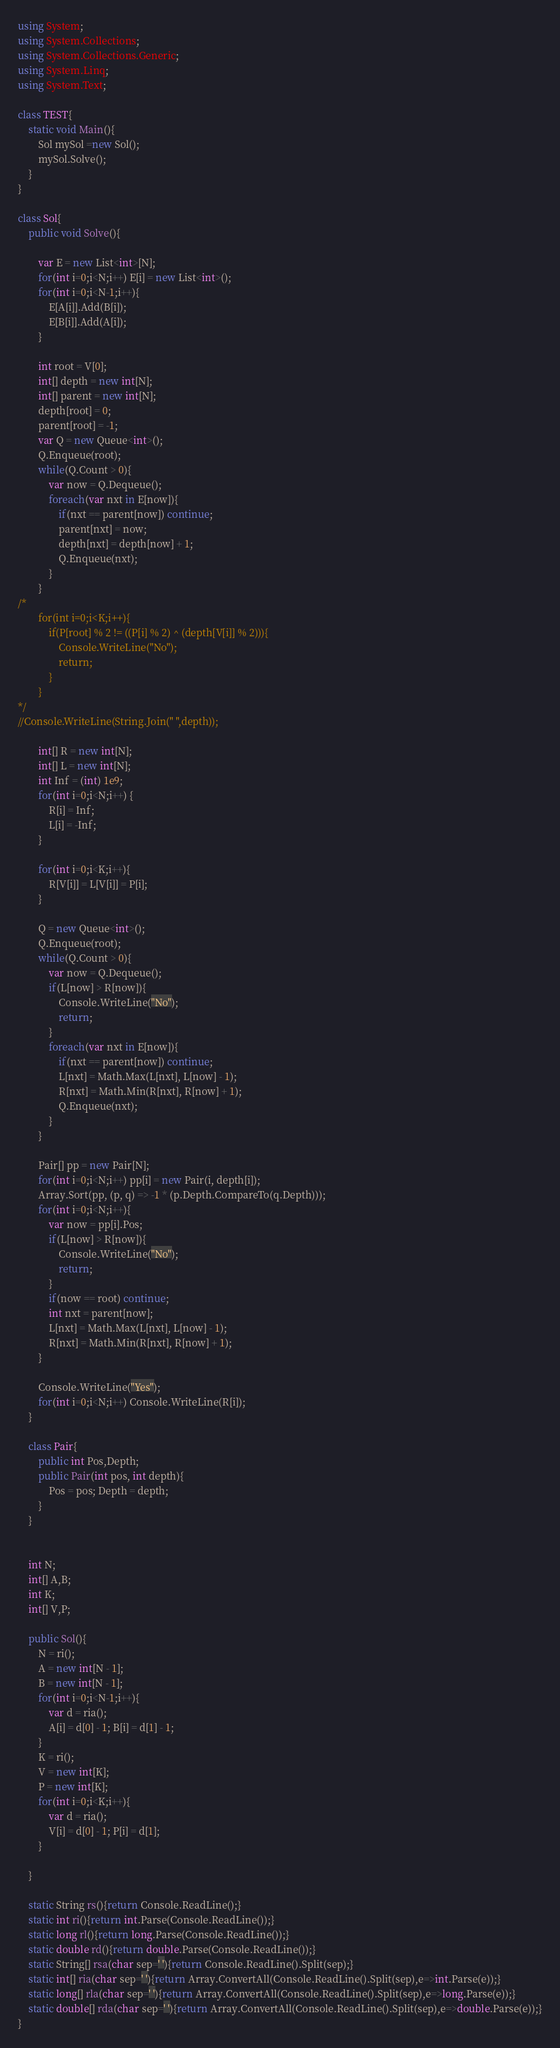Convert code to text. <code><loc_0><loc_0><loc_500><loc_500><_C#_>using System;
using System.Collections;
using System.Collections.Generic;
using System.Linq;
using System.Text;

class TEST{
	static void Main(){
		Sol mySol =new Sol();
		mySol.Solve();
	}
}

class Sol{
	public void Solve(){
		
		var E = new List<int>[N];
		for(int i=0;i<N;i++) E[i] = new List<int>();
		for(int i=0;i<N-1;i++){
			E[A[i]].Add(B[i]);
			E[B[i]].Add(A[i]);
		}
		
		int root = V[0];
		int[] depth = new int[N];
		int[] parent = new int[N];
		depth[root] = 0;
		parent[root] = -1;
		var Q = new Queue<int>();
		Q.Enqueue(root);
		while(Q.Count > 0){
			var now = Q.Dequeue();
			foreach(var nxt in E[now]){
				if(nxt == parent[now]) continue;
				parent[nxt] = now;
				depth[nxt] = depth[now] + 1;
				Q.Enqueue(nxt);
			}
		}
/*
		for(int i=0;i<K;i++){
			if(P[root] % 2 != ((P[i] % 2) ^ (depth[V[i]] % 2))){
				Console.WriteLine("No");
				return;
			}
		}
*/
//Console.WriteLine(String.Join(" ",depth));		
		
		int[] R = new int[N];
		int[] L = new int[N];
		int Inf = (int) 1e9;
		for(int i=0;i<N;i++) {
			R[i] = Inf;
			L[i] = -Inf;
		}
		
		for(int i=0;i<K;i++){
			R[V[i]] = L[V[i]] = P[i];
		}
		
		Q = new Queue<int>();
		Q.Enqueue(root);
		while(Q.Count > 0){
			var now = Q.Dequeue();
			if(L[now] > R[now]){
				Console.WriteLine("No");
				return;
			}
			foreach(var nxt in E[now]){
				if(nxt == parent[now]) continue;
				L[nxt] = Math.Max(L[nxt], L[now] - 1);
				R[nxt] = Math.Min(R[nxt], R[now] + 1);
				Q.Enqueue(nxt);
			}
		}
		
		Pair[] pp = new Pair[N];
		for(int i=0;i<N;i++) pp[i] = new Pair(i, depth[i]);
		Array.Sort(pp, (p, q) => -1 * (p.Depth.CompareTo(q.Depth)));
		for(int i=0;i<N;i++){
			var now = pp[i].Pos;
			if(L[now] > R[now]){
				Console.WriteLine("No");
				return;
			}
			if(now == root) continue;
			int nxt = parent[now];
			L[nxt] = Math.Max(L[nxt], L[now] - 1);
			R[nxt] = Math.Min(R[nxt], R[now] + 1);
		}
		
		Console.WriteLine("Yes");
		for(int i=0;i<N;i++) Console.WriteLine(R[i]);
	}
	
	class Pair{
		public int Pos,Depth;
		public Pair(int pos, int depth){
			Pos = pos; Depth = depth;
		}
	}
	
	
	int N;
	int[] A,B;
	int K;
	int[] V,P;
	
	public Sol(){
		N = ri();
		A = new int[N - 1];
		B = new int[N - 1];
		for(int i=0;i<N-1;i++){
			var d = ria();
			A[i] = d[0] - 1; B[i] = d[1] - 1;
		}
		K = ri();
		V = new int[K];
		P = new int[K];
		for(int i=0;i<K;i++){
			var d = ria();
			V[i] = d[0] - 1; P[i] = d[1];
		}
		
	}

	static String rs(){return Console.ReadLine();}
	static int ri(){return int.Parse(Console.ReadLine());}
	static long rl(){return long.Parse(Console.ReadLine());}
	static double rd(){return double.Parse(Console.ReadLine());}
	static String[] rsa(char sep=' '){return Console.ReadLine().Split(sep);}
	static int[] ria(char sep=' '){return Array.ConvertAll(Console.ReadLine().Split(sep),e=>int.Parse(e));}
	static long[] rla(char sep=' '){return Array.ConvertAll(Console.ReadLine().Split(sep),e=>long.Parse(e));}
	static double[] rda(char sep=' '){return Array.ConvertAll(Console.ReadLine().Split(sep),e=>double.Parse(e));}
}
</code> 